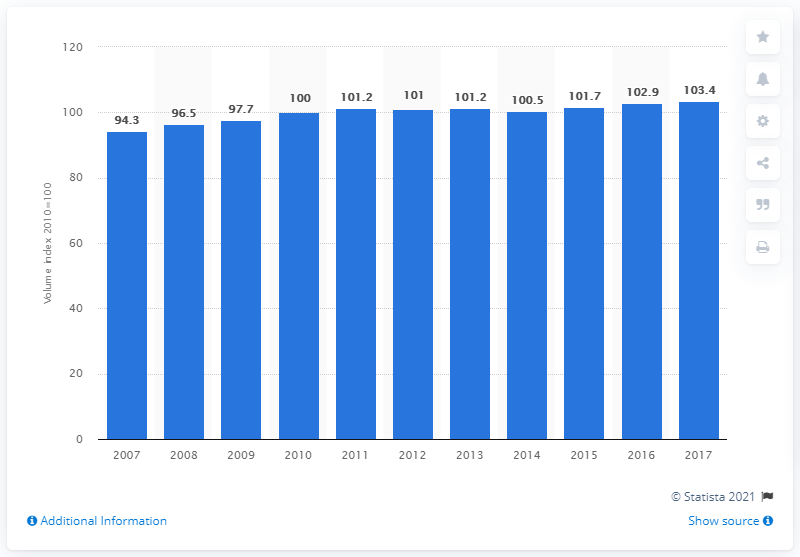Point out several critical features in this image. In 2017, the volume index of households' adjusted disposable income in Finland was 103.4. This indicates that the adjusted disposable income of households in Finland increased by 103.4% compared to the previous year. 